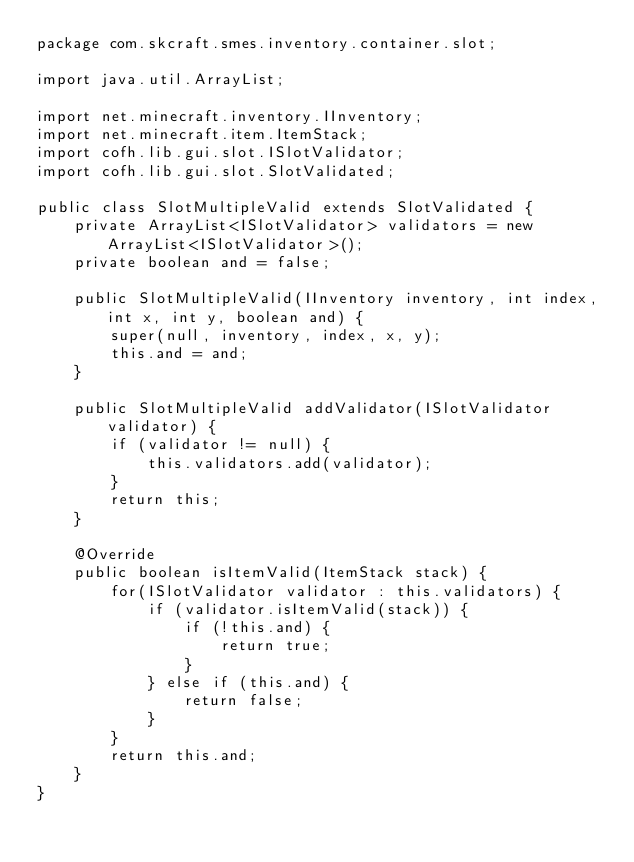<code> <loc_0><loc_0><loc_500><loc_500><_Java_>package com.skcraft.smes.inventory.container.slot;

import java.util.ArrayList;

import net.minecraft.inventory.IInventory;
import net.minecraft.item.ItemStack;
import cofh.lib.gui.slot.ISlotValidator;
import cofh.lib.gui.slot.SlotValidated;

public class SlotMultipleValid extends SlotValidated {
    private ArrayList<ISlotValidator> validators = new ArrayList<ISlotValidator>();
    private boolean and = false;
    
    public SlotMultipleValid(IInventory inventory, int index, int x, int y, boolean and) {
        super(null, inventory, index, x, y);
        this.and = and;
    }
    
    public SlotMultipleValid addValidator(ISlotValidator validator) {
        if (validator != null) {
            this.validators.add(validator);
        }
        return this;
    }
    
    @Override
    public boolean isItemValid(ItemStack stack) {
        for(ISlotValidator validator : this.validators) {
            if (validator.isItemValid(stack)) {
                if (!this.and) {
                    return true;
                }
            } else if (this.and) {
                return false;
            }
        }
        return this.and;
    }
}
</code> 